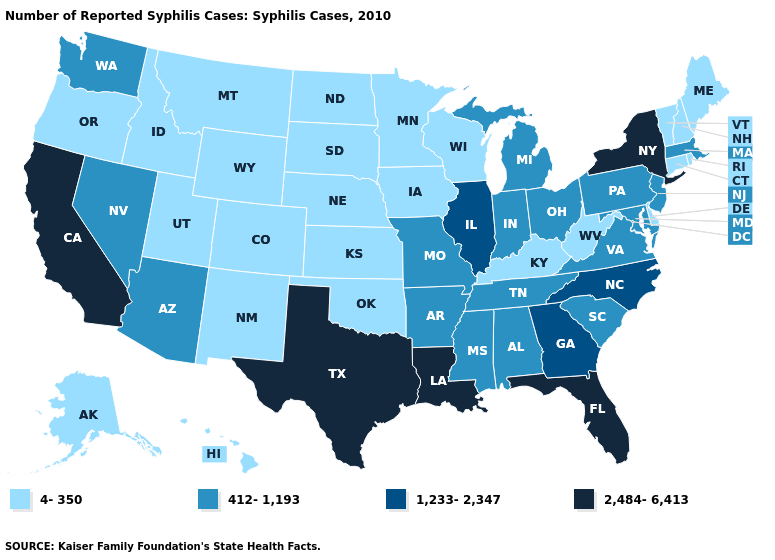What is the value of Minnesota?
Be succinct. 4-350. What is the lowest value in states that border Connecticut?
Keep it brief. 4-350. Name the states that have a value in the range 412-1,193?
Give a very brief answer. Alabama, Arizona, Arkansas, Indiana, Maryland, Massachusetts, Michigan, Mississippi, Missouri, Nevada, New Jersey, Ohio, Pennsylvania, South Carolina, Tennessee, Virginia, Washington. Name the states that have a value in the range 1,233-2,347?
Short answer required. Georgia, Illinois, North Carolina. Among the states that border New York , does Connecticut have the highest value?
Keep it brief. No. What is the highest value in states that border Montana?
Answer briefly. 4-350. Does the map have missing data?
Give a very brief answer. No. Name the states that have a value in the range 1,233-2,347?
Give a very brief answer. Georgia, Illinois, North Carolina. Is the legend a continuous bar?
Short answer required. No. Name the states that have a value in the range 412-1,193?
Answer briefly. Alabama, Arizona, Arkansas, Indiana, Maryland, Massachusetts, Michigan, Mississippi, Missouri, Nevada, New Jersey, Ohio, Pennsylvania, South Carolina, Tennessee, Virginia, Washington. What is the lowest value in the South?
Write a very short answer. 4-350. What is the value of Mississippi?
Keep it brief. 412-1,193. Does New York have the highest value in the USA?
Concise answer only. Yes. Does Utah have the same value as Iowa?
Be succinct. Yes. What is the value of Illinois?
Be succinct. 1,233-2,347. 